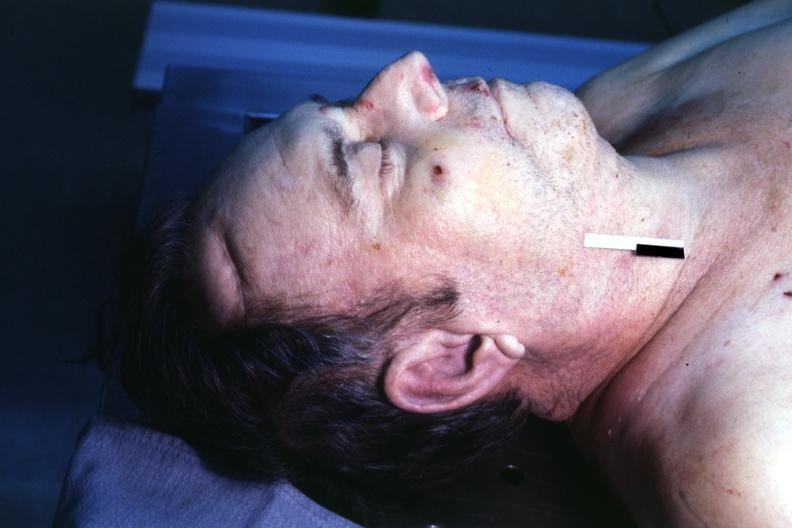what is easily seen?
Answer the question using a single word or phrase. Premature coronary disease 